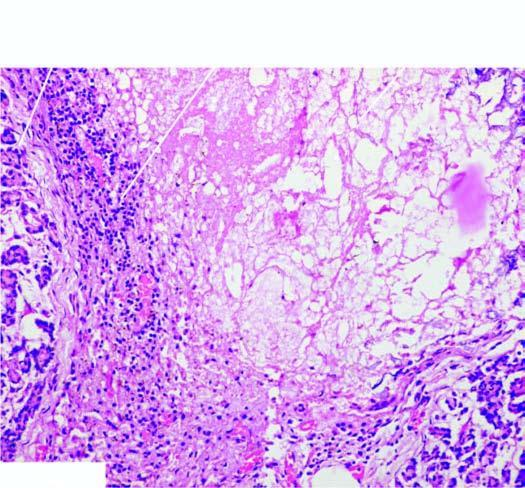s infarcted area surrounded by mixed inflammatory infiltrate with granulation tissue formation?
Answer the question using a single word or phrase. No 